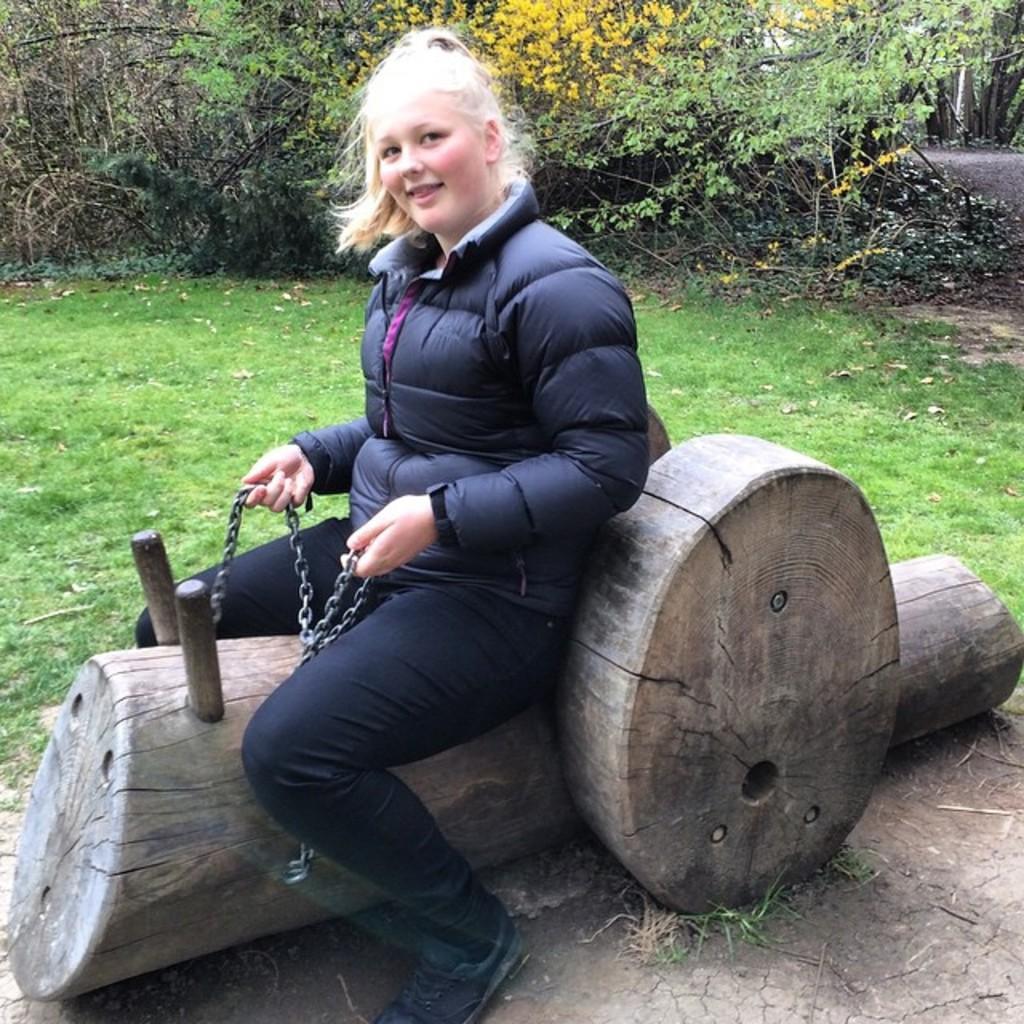Please provide a concise description of this image. In this image I can see a huge wooden log on the ground and a girl wearing black color dress is sitting on the wooden log and holding metal chains in her hand. In the background I can see some grass on the ground and few trees which are green, brown and yellow in color. 